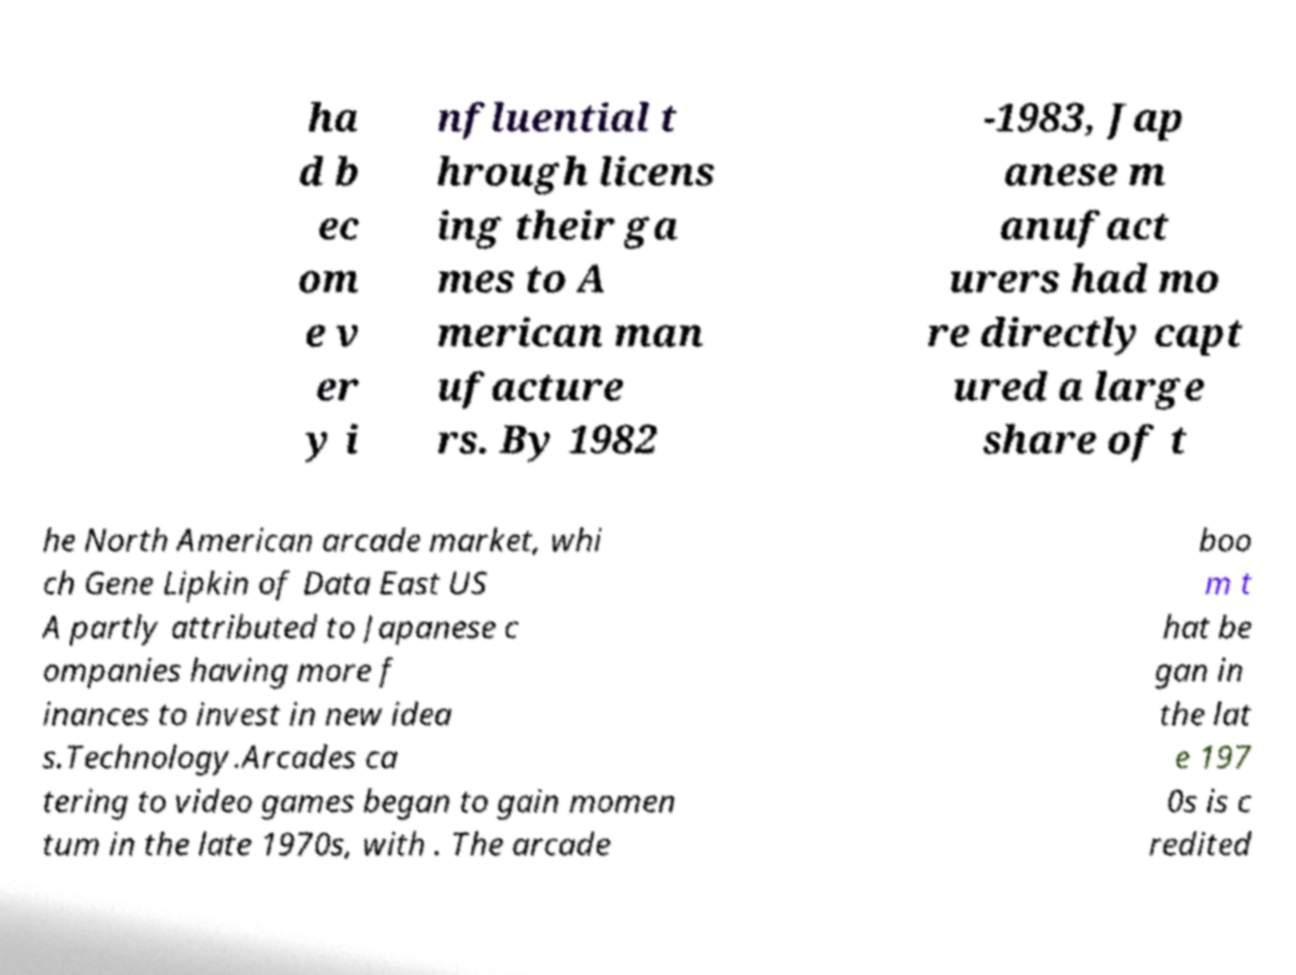Could you extract and type out the text from this image? ha d b ec om e v er y i nfluential t hrough licens ing their ga mes to A merican man ufacture rs. By 1982 -1983, Jap anese m anufact urers had mo re directly capt ured a large share of t he North American arcade market, whi ch Gene Lipkin of Data East US A partly attributed to Japanese c ompanies having more f inances to invest in new idea s.Technology.Arcades ca tering to video games began to gain momen tum in the late 1970s, with . The arcade boo m t hat be gan in the lat e 197 0s is c redited 